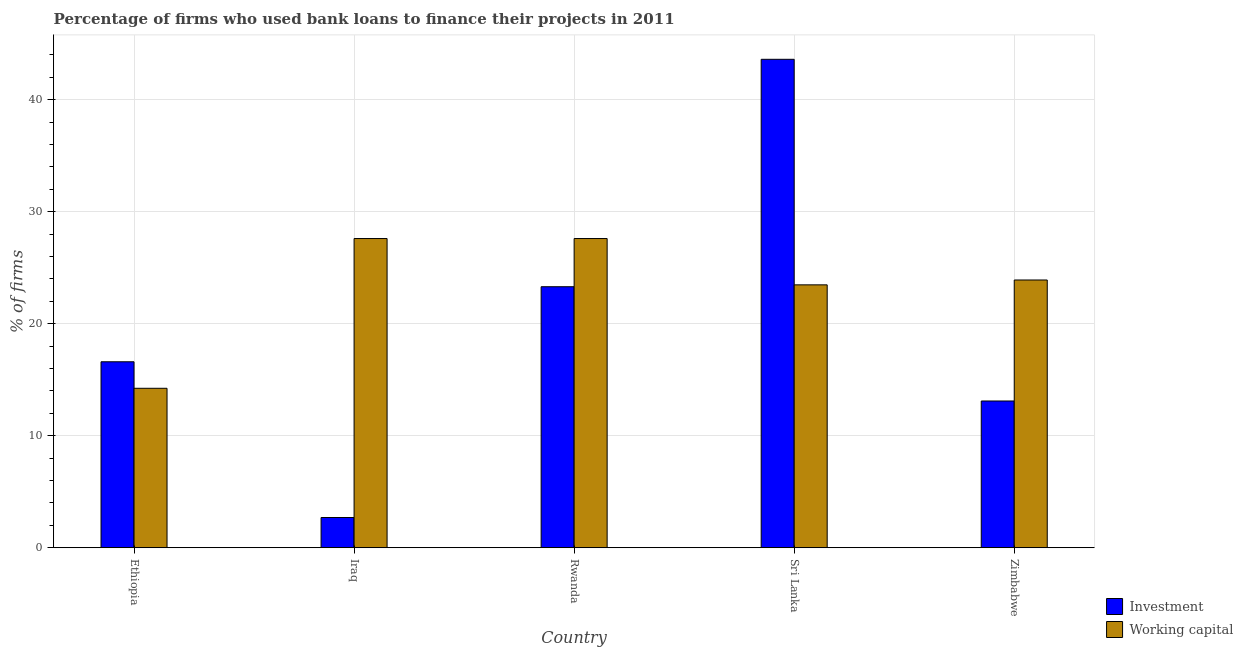How many groups of bars are there?
Your response must be concise. 5. Are the number of bars per tick equal to the number of legend labels?
Your answer should be very brief. Yes. Are the number of bars on each tick of the X-axis equal?
Give a very brief answer. Yes. What is the label of the 3rd group of bars from the left?
Your answer should be very brief. Rwanda. Across all countries, what is the maximum percentage of firms using banks to finance investment?
Offer a very short reply. 43.6. In which country was the percentage of firms using banks to finance investment maximum?
Your answer should be very brief. Sri Lanka. In which country was the percentage of firms using banks to finance investment minimum?
Your response must be concise. Iraq. What is the total percentage of firms using banks to finance working capital in the graph?
Keep it short and to the point. 116.8. What is the difference between the percentage of firms using banks to finance investment in Ethiopia and that in Zimbabwe?
Provide a short and direct response. 3.5. What is the difference between the percentage of firms using banks to finance investment in Sri Lanka and the percentage of firms using banks to finance working capital in Zimbabwe?
Your response must be concise. 19.7. What is the average percentage of firms using banks to finance working capital per country?
Ensure brevity in your answer.  23.36. What is the difference between the percentage of firms using banks to finance investment and percentage of firms using banks to finance working capital in Zimbabwe?
Keep it short and to the point. -10.8. What is the ratio of the percentage of firms using banks to finance investment in Iraq to that in Sri Lanka?
Your answer should be very brief. 0.06. Is the percentage of firms using banks to finance working capital in Sri Lanka less than that in Zimbabwe?
Your response must be concise. Yes. What is the difference between the highest and the second highest percentage of firms using banks to finance investment?
Make the answer very short. 20.3. What is the difference between the highest and the lowest percentage of firms using banks to finance investment?
Ensure brevity in your answer.  40.9. What does the 2nd bar from the left in Iraq represents?
Provide a short and direct response. Working capital. What does the 2nd bar from the right in Iraq represents?
Your answer should be compact. Investment. Are all the bars in the graph horizontal?
Give a very brief answer. No. What is the difference between two consecutive major ticks on the Y-axis?
Your answer should be very brief. 10. How many legend labels are there?
Your answer should be compact. 2. What is the title of the graph?
Offer a very short reply. Percentage of firms who used bank loans to finance their projects in 2011. Does "Electricity and heat production" appear as one of the legend labels in the graph?
Give a very brief answer. No. What is the label or title of the Y-axis?
Give a very brief answer. % of firms. What is the % of firms in Investment in Ethiopia?
Your response must be concise. 16.6. What is the % of firms of Working capital in Ethiopia?
Give a very brief answer. 14.23. What is the % of firms of Investment in Iraq?
Give a very brief answer. 2.7. What is the % of firms of Working capital in Iraq?
Give a very brief answer. 27.6. What is the % of firms in Investment in Rwanda?
Your answer should be very brief. 23.3. What is the % of firms of Working capital in Rwanda?
Your response must be concise. 27.6. What is the % of firms of Investment in Sri Lanka?
Give a very brief answer. 43.6. What is the % of firms of Working capital in Sri Lanka?
Your response must be concise. 23.47. What is the % of firms in Working capital in Zimbabwe?
Provide a succinct answer. 23.9. Across all countries, what is the maximum % of firms in Investment?
Offer a terse response. 43.6. Across all countries, what is the maximum % of firms in Working capital?
Provide a succinct answer. 27.6. Across all countries, what is the minimum % of firms of Investment?
Make the answer very short. 2.7. Across all countries, what is the minimum % of firms of Working capital?
Your answer should be very brief. 14.23. What is the total % of firms in Investment in the graph?
Keep it short and to the point. 99.3. What is the total % of firms in Working capital in the graph?
Offer a very short reply. 116.8. What is the difference between the % of firms in Investment in Ethiopia and that in Iraq?
Give a very brief answer. 13.9. What is the difference between the % of firms in Working capital in Ethiopia and that in Iraq?
Offer a very short reply. -13.37. What is the difference between the % of firms of Working capital in Ethiopia and that in Rwanda?
Offer a very short reply. -13.37. What is the difference between the % of firms of Working capital in Ethiopia and that in Sri Lanka?
Keep it short and to the point. -9.23. What is the difference between the % of firms of Investment in Ethiopia and that in Zimbabwe?
Make the answer very short. 3.5. What is the difference between the % of firms of Working capital in Ethiopia and that in Zimbabwe?
Ensure brevity in your answer.  -9.67. What is the difference between the % of firms in Investment in Iraq and that in Rwanda?
Your answer should be compact. -20.6. What is the difference between the % of firms in Investment in Iraq and that in Sri Lanka?
Offer a terse response. -40.9. What is the difference between the % of firms of Working capital in Iraq and that in Sri Lanka?
Provide a succinct answer. 4.13. What is the difference between the % of firms of Investment in Iraq and that in Zimbabwe?
Your response must be concise. -10.4. What is the difference between the % of firms in Working capital in Iraq and that in Zimbabwe?
Give a very brief answer. 3.7. What is the difference between the % of firms of Investment in Rwanda and that in Sri Lanka?
Provide a short and direct response. -20.3. What is the difference between the % of firms in Working capital in Rwanda and that in Sri Lanka?
Your answer should be very brief. 4.13. What is the difference between the % of firms in Working capital in Rwanda and that in Zimbabwe?
Offer a very short reply. 3.7. What is the difference between the % of firms in Investment in Sri Lanka and that in Zimbabwe?
Ensure brevity in your answer.  30.5. What is the difference between the % of firms of Working capital in Sri Lanka and that in Zimbabwe?
Ensure brevity in your answer.  -0.43. What is the difference between the % of firms in Investment in Ethiopia and the % of firms in Working capital in Iraq?
Provide a succinct answer. -11. What is the difference between the % of firms in Investment in Ethiopia and the % of firms in Working capital in Sri Lanka?
Ensure brevity in your answer.  -6.87. What is the difference between the % of firms in Investment in Iraq and the % of firms in Working capital in Rwanda?
Keep it short and to the point. -24.9. What is the difference between the % of firms of Investment in Iraq and the % of firms of Working capital in Sri Lanka?
Ensure brevity in your answer.  -20.77. What is the difference between the % of firms of Investment in Iraq and the % of firms of Working capital in Zimbabwe?
Ensure brevity in your answer.  -21.2. What is the average % of firms in Investment per country?
Ensure brevity in your answer.  19.86. What is the average % of firms of Working capital per country?
Provide a succinct answer. 23.36. What is the difference between the % of firms in Investment and % of firms in Working capital in Ethiopia?
Your response must be concise. 2.37. What is the difference between the % of firms of Investment and % of firms of Working capital in Iraq?
Provide a short and direct response. -24.9. What is the difference between the % of firms of Investment and % of firms of Working capital in Rwanda?
Your response must be concise. -4.3. What is the difference between the % of firms in Investment and % of firms in Working capital in Sri Lanka?
Keep it short and to the point. 20.13. What is the ratio of the % of firms of Investment in Ethiopia to that in Iraq?
Provide a short and direct response. 6.15. What is the ratio of the % of firms in Working capital in Ethiopia to that in Iraq?
Offer a terse response. 0.52. What is the ratio of the % of firms in Investment in Ethiopia to that in Rwanda?
Offer a very short reply. 0.71. What is the ratio of the % of firms in Working capital in Ethiopia to that in Rwanda?
Give a very brief answer. 0.52. What is the ratio of the % of firms of Investment in Ethiopia to that in Sri Lanka?
Provide a succinct answer. 0.38. What is the ratio of the % of firms of Working capital in Ethiopia to that in Sri Lanka?
Your answer should be very brief. 0.61. What is the ratio of the % of firms in Investment in Ethiopia to that in Zimbabwe?
Offer a very short reply. 1.27. What is the ratio of the % of firms in Working capital in Ethiopia to that in Zimbabwe?
Your response must be concise. 0.6. What is the ratio of the % of firms of Investment in Iraq to that in Rwanda?
Offer a very short reply. 0.12. What is the ratio of the % of firms of Working capital in Iraq to that in Rwanda?
Make the answer very short. 1. What is the ratio of the % of firms of Investment in Iraq to that in Sri Lanka?
Offer a terse response. 0.06. What is the ratio of the % of firms in Working capital in Iraq to that in Sri Lanka?
Keep it short and to the point. 1.18. What is the ratio of the % of firms in Investment in Iraq to that in Zimbabwe?
Your answer should be very brief. 0.21. What is the ratio of the % of firms in Working capital in Iraq to that in Zimbabwe?
Offer a very short reply. 1.15. What is the ratio of the % of firms in Investment in Rwanda to that in Sri Lanka?
Your answer should be compact. 0.53. What is the ratio of the % of firms of Working capital in Rwanda to that in Sri Lanka?
Give a very brief answer. 1.18. What is the ratio of the % of firms in Investment in Rwanda to that in Zimbabwe?
Make the answer very short. 1.78. What is the ratio of the % of firms in Working capital in Rwanda to that in Zimbabwe?
Offer a very short reply. 1.15. What is the ratio of the % of firms of Investment in Sri Lanka to that in Zimbabwe?
Offer a very short reply. 3.33. What is the ratio of the % of firms in Working capital in Sri Lanka to that in Zimbabwe?
Provide a succinct answer. 0.98. What is the difference between the highest and the second highest % of firms of Investment?
Make the answer very short. 20.3. What is the difference between the highest and the second highest % of firms of Working capital?
Your answer should be compact. 0. What is the difference between the highest and the lowest % of firms of Investment?
Offer a very short reply. 40.9. What is the difference between the highest and the lowest % of firms in Working capital?
Give a very brief answer. 13.37. 